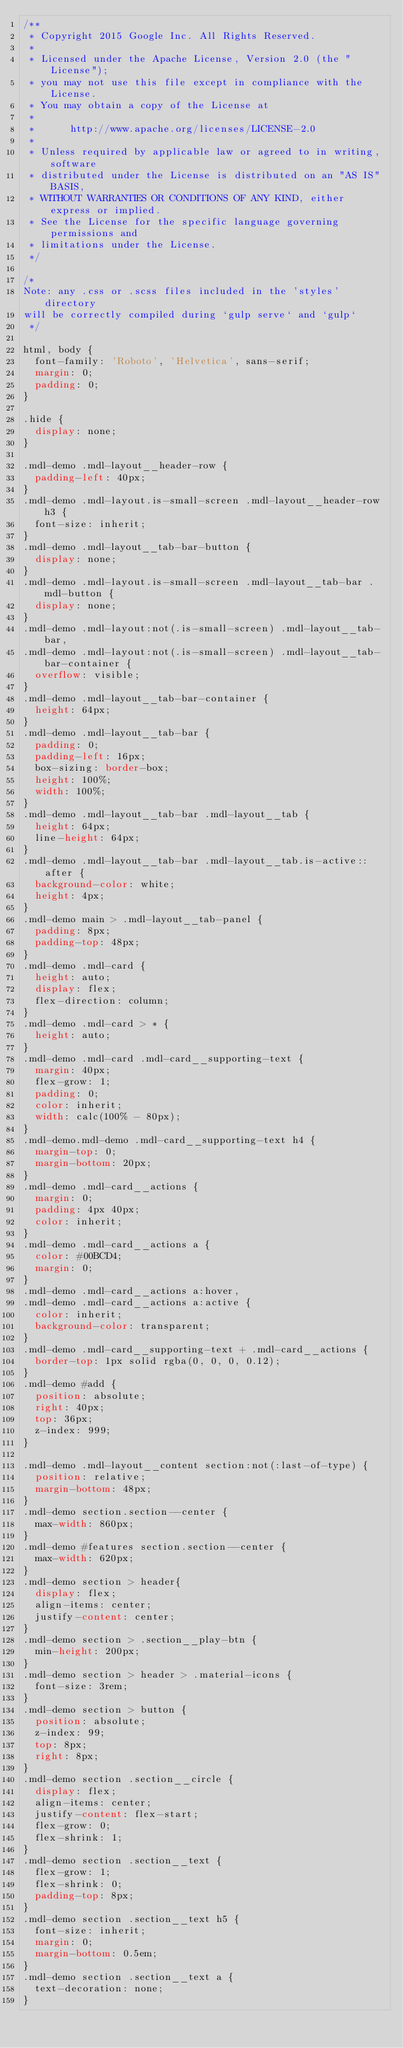<code> <loc_0><loc_0><loc_500><loc_500><_CSS_>/**
 * Copyright 2015 Google Inc. All Rights Reserved.
 *
 * Licensed under the Apache License, Version 2.0 (the "License");
 * you may not use this file except in compliance with the License.
 * You may obtain a copy of the License at
 *
 *      http://www.apache.org/licenses/LICENSE-2.0
 *
 * Unless required by applicable law or agreed to in writing, software
 * distributed under the License is distributed on an "AS IS" BASIS,
 * WITHOUT WARRANTIES OR CONDITIONS OF ANY KIND, either express or implied.
 * See the License for the specific language governing permissions and
 * limitations under the License.
 */

/*
Note: any .css or .scss files included in the 'styles' directory
will be correctly compiled during `gulp serve` and `gulp`
 */

html, body {
  font-family: 'Roboto', 'Helvetica', sans-serif;
  margin: 0;
  padding: 0;
}

.hide {
  display: none;
}

.mdl-demo .mdl-layout__header-row {
  padding-left: 40px;
}
.mdl-demo .mdl-layout.is-small-screen .mdl-layout__header-row h3 {
  font-size: inherit;
}
.mdl-demo .mdl-layout__tab-bar-button {
  display: none;
}
.mdl-demo .mdl-layout.is-small-screen .mdl-layout__tab-bar .mdl-button {
  display: none;
}
.mdl-demo .mdl-layout:not(.is-small-screen) .mdl-layout__tab-bar,
.mdl-demo .mdl-layout:not(.is-small-screen) .mdl-layout__tab-bar-container {
  overflow: visible;
}
.mdl-demo .mdl-layout__tab-bar-container {
  height: 64px;
}
.mdl-demo .mdl-layout__tab-bar {
  padding: 0;
  padding-left: 16px;
  box-sizing: border-box;
  height: 100%;
  width: 100%;
}
.mdl-demo .mdl-layout__tab-bar .mdl-layout__tab {
  height: 64px;
  line-height: 64px;
}
.mdl-demo .mdl-layout__tab-bar .mdl-layout__tab.is-active::after {
  background-color: white;
  height: 4px;
}
.mdl-demo main > .mdl-layout__tab-panel {
  padding: 8px;
  padding-top: 48px;
}
.mdl-demo .mdl-card {
  height: auto;
  display: flex;
  flex-direction: column;
}
.mdl-demo .mdl-card > * {
  height: auto;
}
.mdl-demo .mdl-card .mdl-card__supporting-text {
  margin: 40px;
  flex-grow: 1;
  padding: 0;
  color: inherit;
  width: calc(100% - 80px);
}
.mdl-demo.mdl-demo .mdl-card__supporting-text h4 {
  margin-top: 0;
  margin-bottom: 20px;
}
.mdl-demo .mdl-card__actions {
  margin: 0;
  padding: 4px 40px;
  color: inherit;
}
.mdl-demo .mdl-card__actions a {
  color: #00BCD4;
  margin: 0;
}
.mdl-demo .mdl-card__actions a:hover,
.mdl-demo .mdl-card__actions a:active {
  color: inherit;
  background-color: transparent;
}
.mdl-demo .mdl-card__supporting-text + .mdl-card__actions {
  border-top: 1px solid rgba(0, 0, 0, 0.12);
}
.mdl-demo #add {
  position: absolute;
  right: 40px;
  top: 36px;
  z-index: 999;
}

.mdl-demo .mdl-layout__content section:not(:last-of-type) {
  position: relative;
  margin-bottom: 48px;
}
.mdl-demo section.section--center {
  max-width: 860px;
}
.mdl-demo #features section.section--center {
  max-width: 620px;
}
.mdl-demo section > header{
  display: flex;
  align-items: center;
  justify-content: center;
}
.mdl-demo section > .section__play-btn {
  min-height: 200px;
}
.mdl-demo section > header > .material-icons {
  font-size: 3rem;
}
.mdl-demo section > button {
  position: absolute;
  z-index: 99;
  top: 8px;
  right: 8px;
}
.mdl-demo section .section__circle {
  display: flex;
  align-items: center;
  justify-content: flex-start;
  flex-grow: 0;
  flex-shrink: 1;
}
.mdl-demo section .section__text {
  flex-grow: 1;
  flex-shrink: 0;
  padding-top: 8px;
}
.mdl-demo section .section__text h5 {
  font-size: inherit;
  margin: 0;
  margin-bottom: 0.5em;
}
.mdl-demo section .section__text a {
  text-decoration: none;
}</code> 